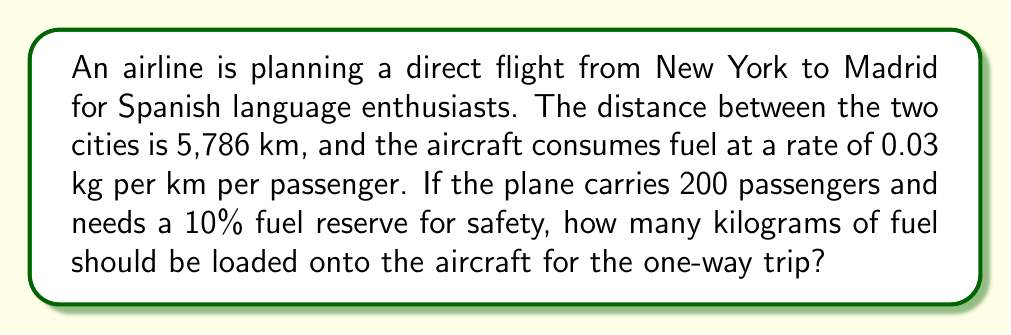Can you answer this question? Let's break this down step-by-step:

1) First, calculate the fuel consumption for the trip without the reserve:
   
   Fuel consumption = Distance × Fuel rate × Number of passengers
   $$F = 5,786 \text{ km} \times 0.03 \frac{\text{kg}}{\text{km} \cdot \text{passenger}} \times 200 \text{ passengers}$$
   $$F = 34,716 \text{ kg}$$

2) Now, we need to add a 10% reserve. To do this, we multiply the fuel consumption by 1.1:
   
   Total fuel needed = Fuel consumption × 1.1
   $$F_{\text{total}} = 34,716 \text{ kg} \times 1.1$$
   $$F_{\text{total}} = 38,187.6 \text{ kg}$$

3) Rounding up to the nearest kilogram for safety:
   
   $$F_{\text{total}} = 38,188 \text{ kg}$$

Therefore, the aircraft should be loaded with 38,188 kg of fuel for the one-way trip from New York to Madrid.
Answer: 38,188 kg 